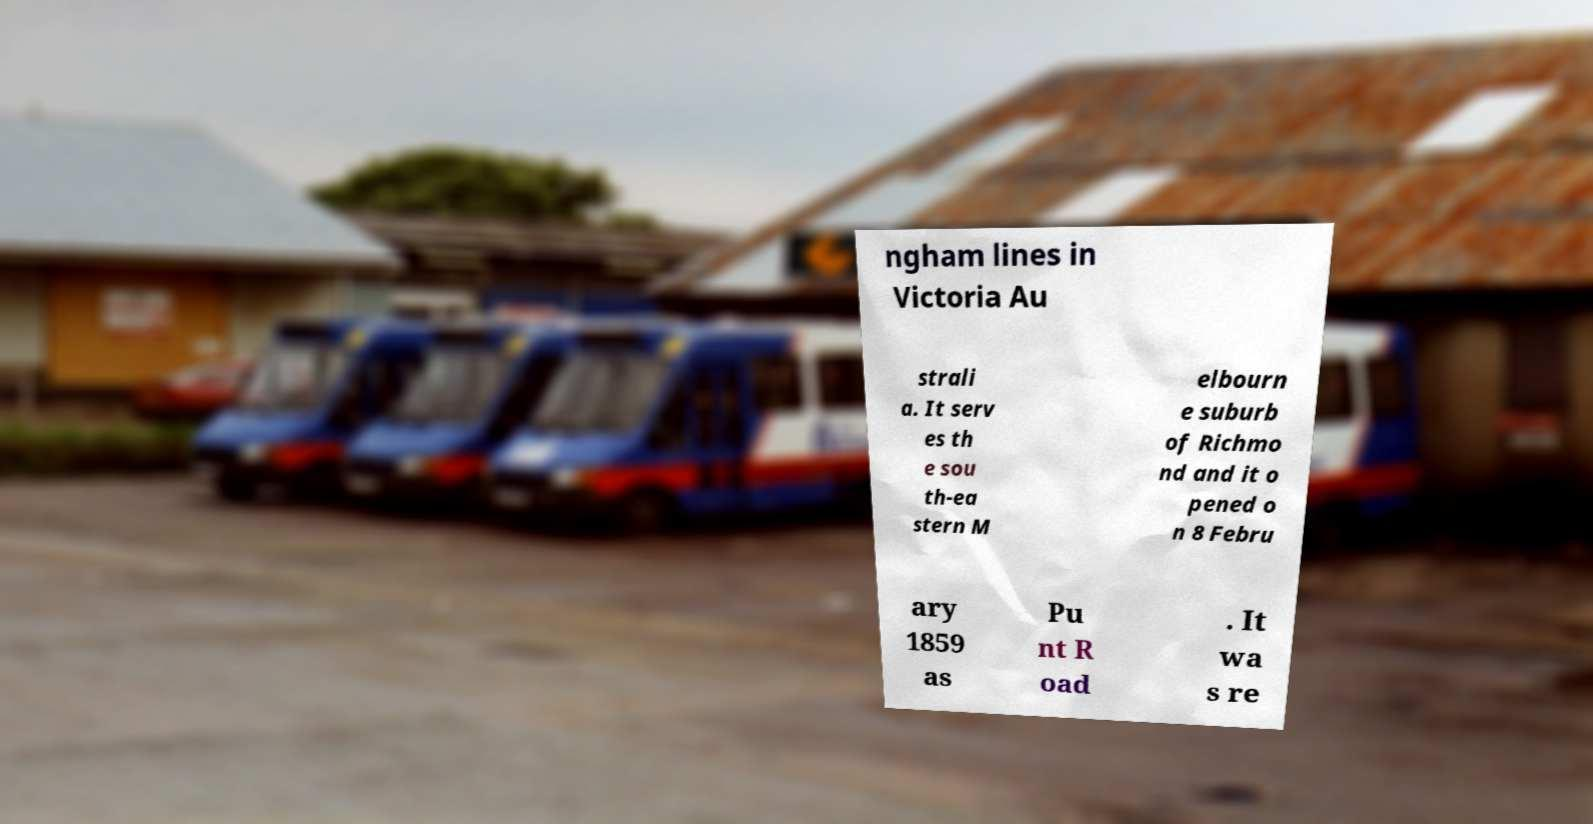Could you assist in decoding the text presented in this image and type it out clearly? ngham lines in Victoria Au strali a. It serv es th e sou th-ea stern M elbourn e suburb of Richmo nd and it o pened o n 8 Febru ary 1859 as Pu nt R oad . It wa s re 